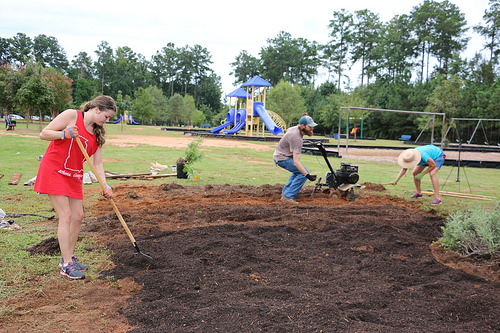<image>
Is there a playground above the man? No. The playground is not positioned above the man. The vertical arrangement shows a different relationship. 